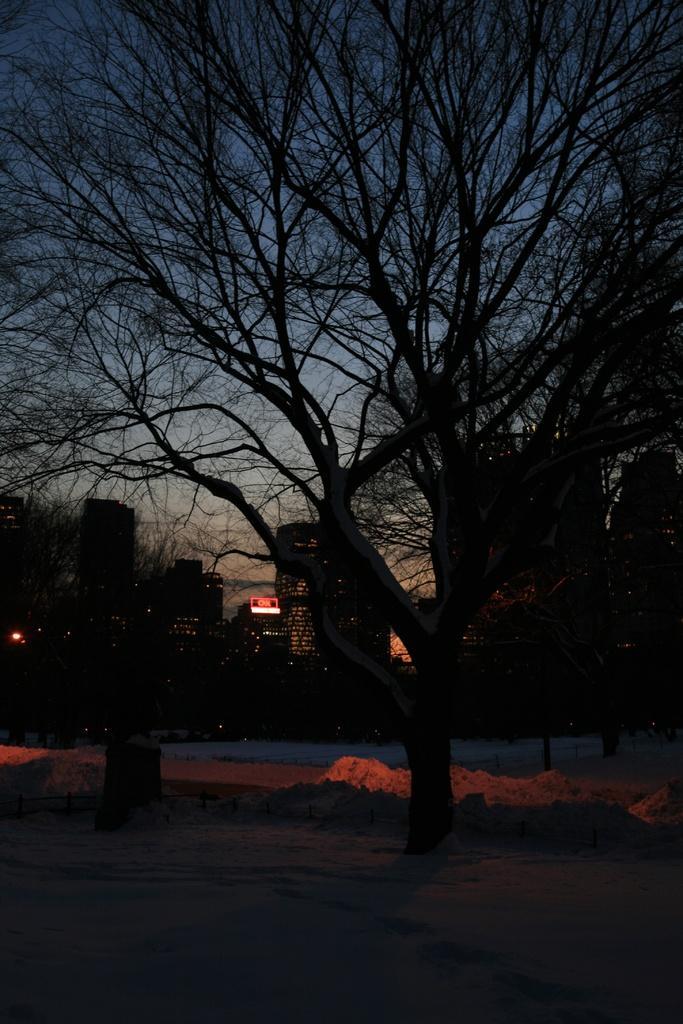In one or two sentences, can you explain what this image depicts? In this image I can see the tree and the sky and building and the image is taken in night 